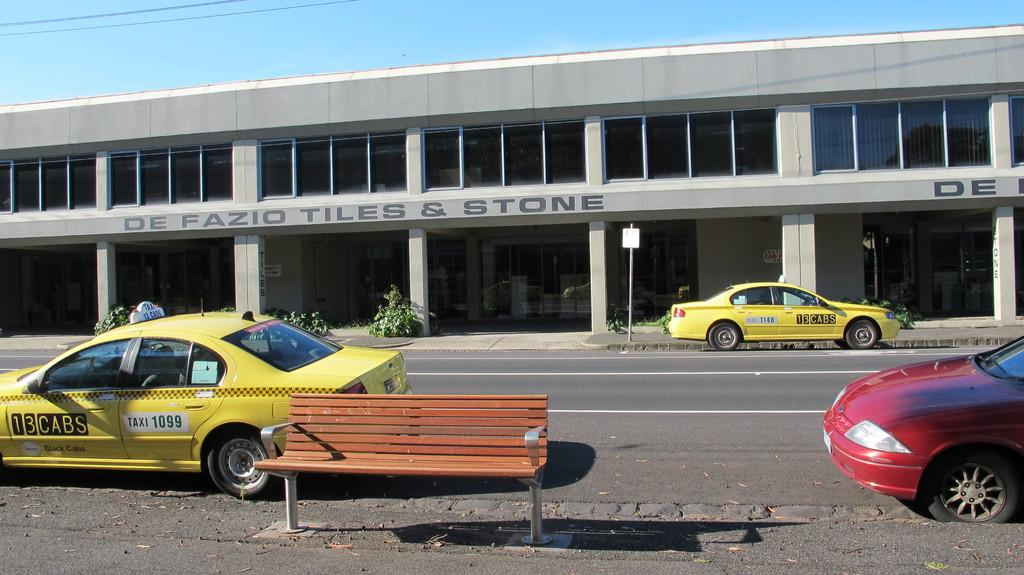<image>
Render a clear and concise summary of the photo. the front of a building with the name de fazio tiles and stone. 